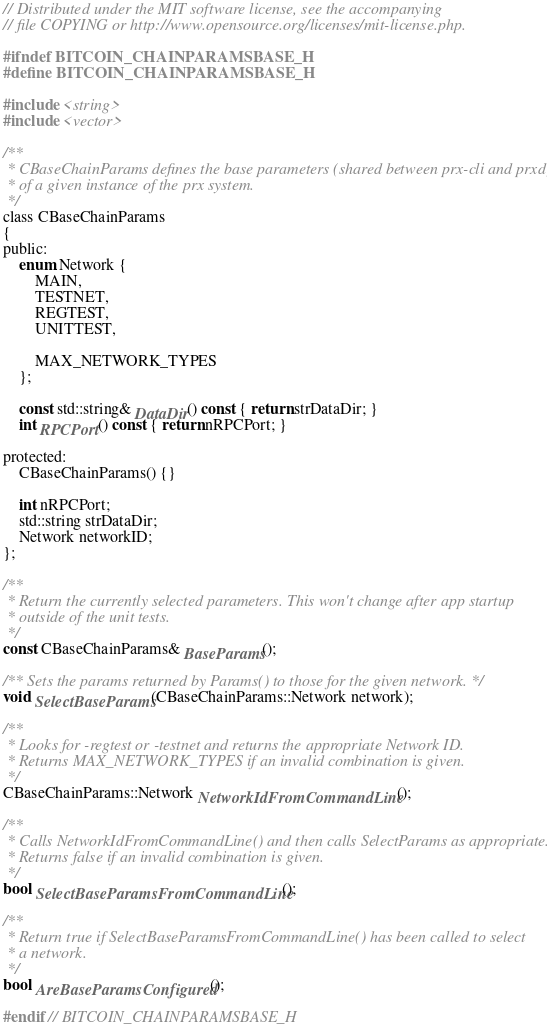<code> <loc_0><loc_0><loc_500><loc_500><_C_>// Distributed under the MIT software license, see the accompanying
// file COPYING or http://www.opensource.org/licenses/mit-license.php.

#ifndef BITCOIN_CHAINPARAMSBASE_H
#define BITCOIN_CHAINPARAMSBASE_H

#include <string>
#include <vector>

/**
 * CBaseChainParams defines the base parameters (shared between prx-cli and prxd)
 * of a given instance of the prx system.
 */
class CBaseChainParams
{
public:
    enum Network {
        MAIN,
        TESTNET,
        REGTEST,
        UNITTEST,

        MAX_NETWORK_TYPES
    };

    const std::string& DataDir() const { return strDataDir; }
    int RPCPort() const { return nRPCPort; }

protected:
    CBaseChainParams() {}

    int nRPCPort;
    std::string strDataDir;
    Network networkID;
};

/**
 * Return the currently selected parameters. This won't change after app startup
 * outside of the unit tests.
 */
const CBaseChainParams& BaseParams();

/** Sets the params returned by Params() to those for the given network. */
void SelectBaseParams(CBaseChainParams::Network network);

/**
 * Looks for -regtest or -testnet and returns the appropriate Network ID.
 * Returns MAX_NETWORK_TYPES if an invalid combination is given.
 */
CBaseChainParams::Network NetworkIdFromCommandLine();

/**
 * Calls NetworkIdFromCommandLine() and then calls SelectParams as appropriate.
 * Returns false if an invalid combination is given.
 */
bool SelectBaseParamsFromCommandLine();

/**
 * Return true if SelectBaseParamsFromCommandLine() has been called to select
 * a network.
 */
bool AreBaseParamsConfigured();

#endif // BITCOIN_CHAINPARAMSBASE_H
</code> 